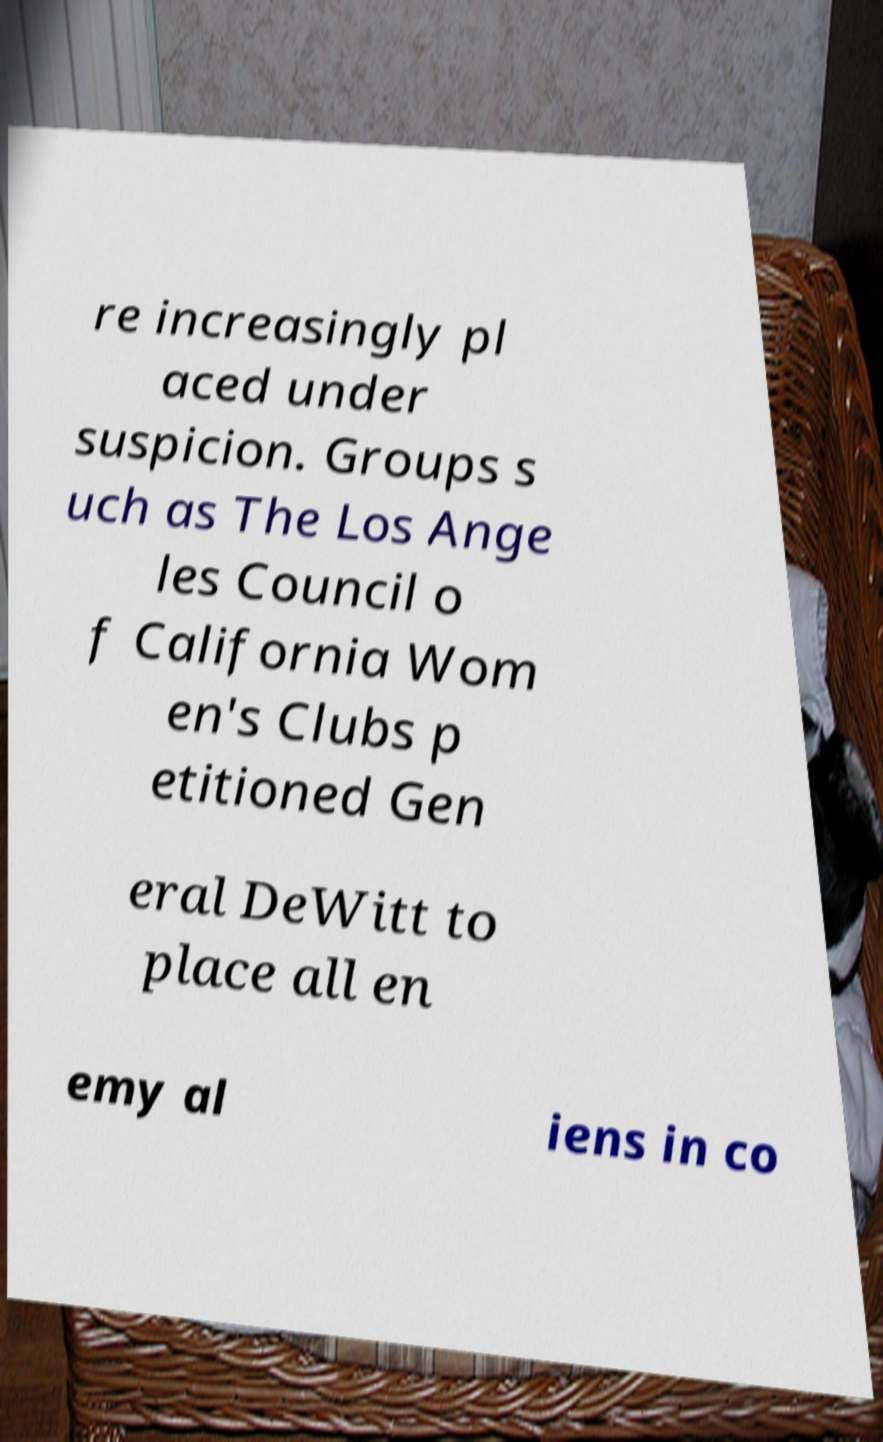For documentation purposes, I need the text within this image transcribed. Could you provide that? re increasingly pl aced under suspicion. Groups s uch as The Los Ange les Council o f California Wom en's Clubs p etitioned Gen eral DeWitt to place all en emy al iens in co 